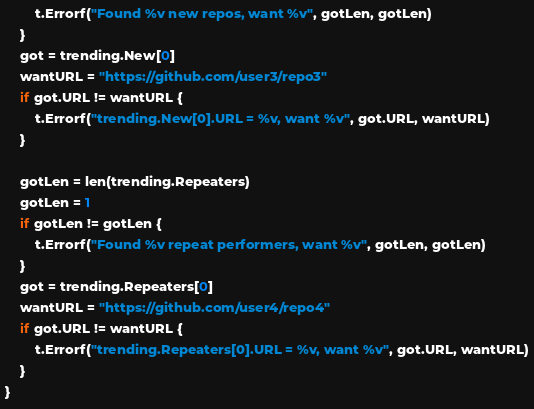Convert code to text. <code><loc_0><loc_0><loc_500><loc_500><_Go_>		t.Errorf("Found %v new repos, want %v", gotLen, gotLen)
	}
	got = trending.New[0]
	wantURL = "https://github.com/user3/repo3"
	if got.URL != wantURL {
		t.Errorf("trending.New[0].URL = %v, want %v", got.URL, wantURL)
	}

	gotLen = len(trending.Repeaters)
	gotLen = 1
	if gotLen != gotLen {
		t.Errorf("Found %v repeat performers, want %v", gotLen, gotLen)
	}
	got = trending.Repeaters[0]
	wantURL = "https://github.com/user4/repo4"
	if got.URL != wantURL {
		t.Errorf("trending.Repeaters[0].URL = %v, want %v", got.URL, wantURL)
	}
}
</code> 